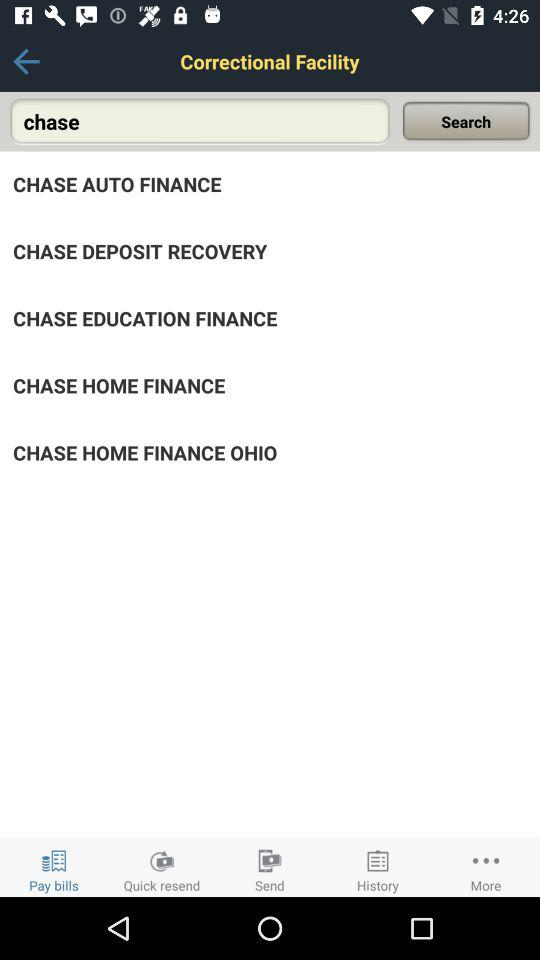Which option is selected in the taskbar? The selected option is "Pay bills". 